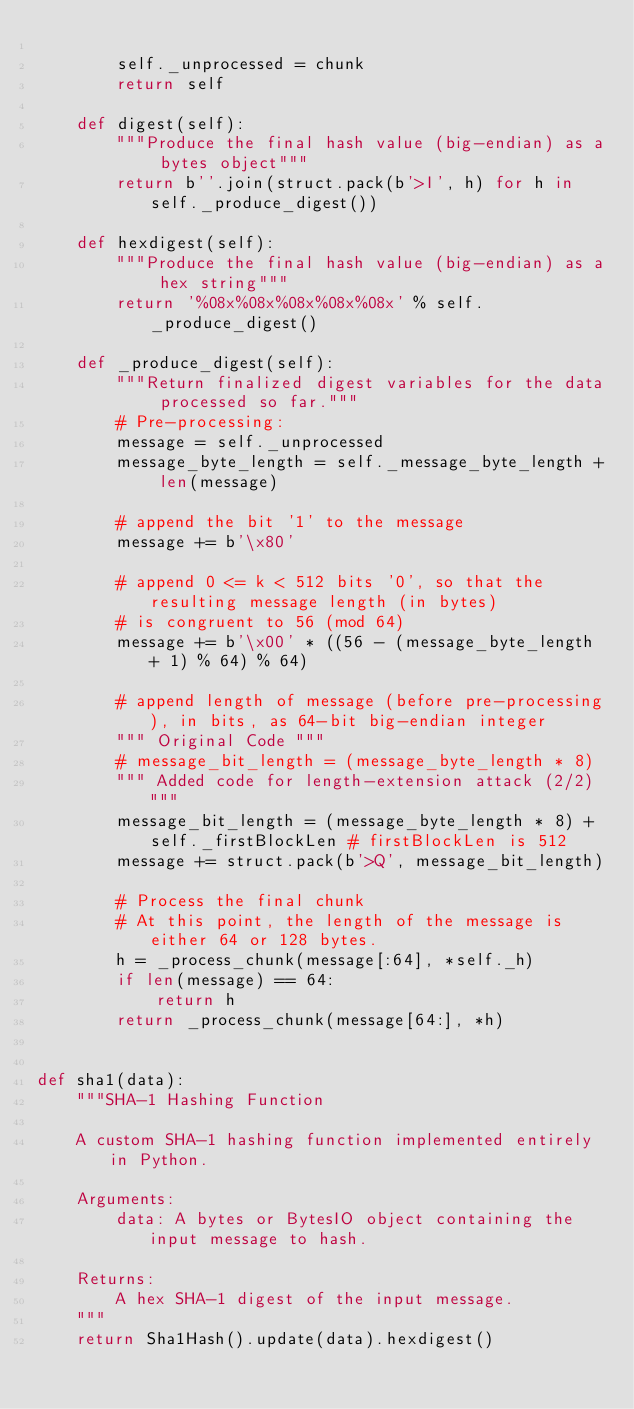Convert code to text. <code><loc_0><loc_0><loc_500><loc_500><_Python_>
        self._unprocessed = chunk
        return self

    def digest(self):
        """Produce the final hash value (big-endian) as a bytes object"""
        return b''.join(struct.pack(b'>I', h) for h in self._produce_digest())

    def hexdigest(self):
        """Produce the final hash value (big-endian) as a hex string"""
        return '%08x%08x%08x%08x%08x' % self._produce_digest()

    def _produce_digest(self):
        """Return finalized digest variables for the data processed so far."""
        # Pre-processing:
        message = self._unprocessed
        message_byte_length = self._message_byte_length + len(message)

        # append the bit '1' to the message
        message += b'\x80'

        # append 0 <= k < 512 bits '0', so that the resulting message length (in bytes)
        # is congruent to 56 (mod 64)
        message += b'\x00' * ((56 - (message_byte_length + 1) % 64) % 64)

        # append length of message (before pre-processing), in bits, as 64-bit big-endian integer
        """ Original Code """
        # message_bit_length = (message_byte_length * 8)
        """ Added code for length-extension attack (2/2) """
        message_bit_length = (message_byte_length * 8) + self._firstBlockLen # firstBlockLen is 512
        message += struct.pack(b'>Q', message_bit_length)

        # Process the final chunk
        # At this point, the length of the message is either 64 or 128 bytes.
        h = _process_chunk(message[:64], *self._h)
        if len(message) == 64:
            return h
        return _process_chunk(message[64:], *h)


def sha1(data):
    """SHA-1 Hashing Function

    A custom SHA-1 hashing function implemented entirely in Python.

    Arguments:
        data: A bytes or BytesIO object containing the input message to hash.

    Returns:
        A hex SHA-1 digest of the input message.
    """
    return Sha1Hash().update(data).hexdigest()

</code> 